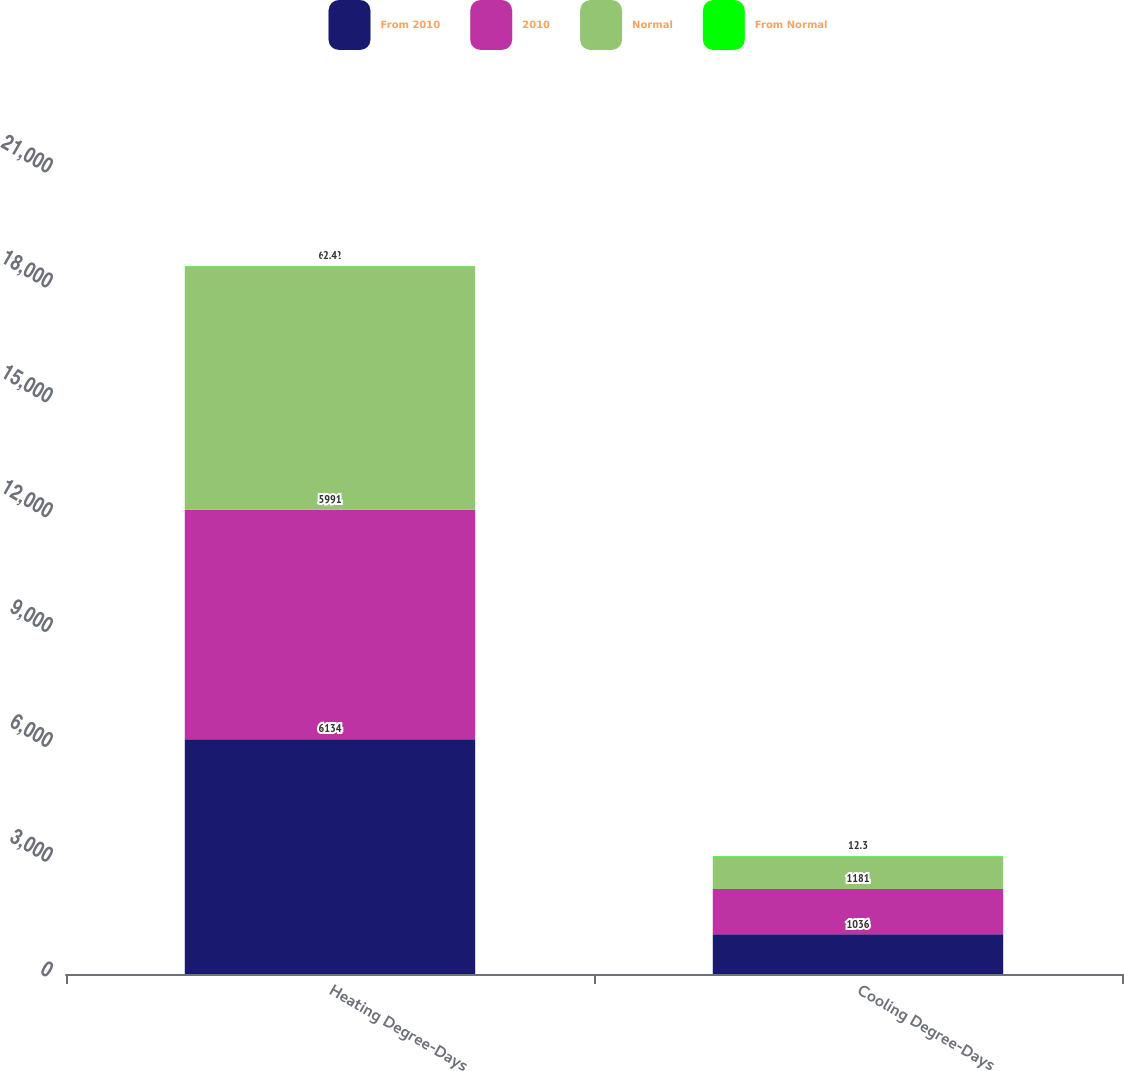<chart> <loc_0><loc_0><loc_500><loc_500><stacked_bar_chart><ecel><fcel>Heating Degree-Days<fcel>Cooling Degree-Days<nl><fcel>From 2010<fcel>6134<fcel>1036<nl><fcel>2010<fcel>5991<fcel>1181<nl><fcel>Normal<fcel>6362<fcel>855<nl><fcel>From Normal<fcel>2.4<fcel>12.3<nl></chart> 